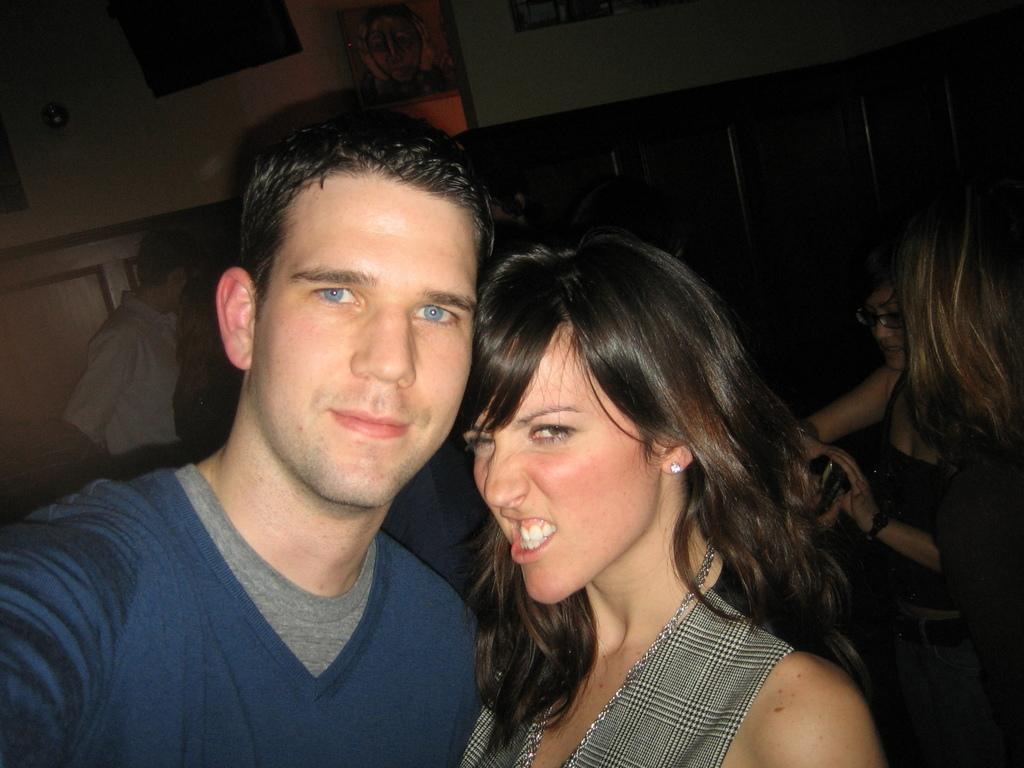How many people are in the image? There is a group of people in the image. What can be observed about the clothing of the people in the image? The people are wearing different color dresses. What can be seen in the background of the image? There are boards on the wall in the background of the image. What type of toy can be seen hanging from the curtain in the image? There is no curtain or toy present in the image. 